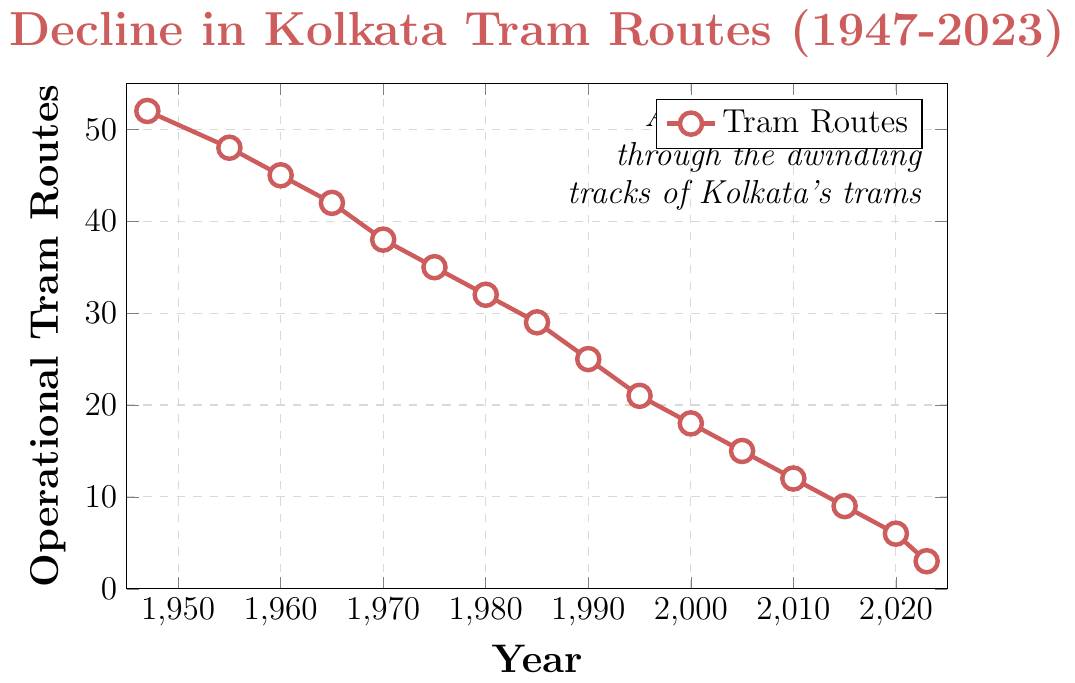What was the number of operational tram routes in 1980? From looking at the figure, the data point for 1980 is at 32.
Answer: 32 How much did the number of tram routes decrease between 1947 and 1965? The number of operational tram routes in 1947 was 52 and in 1965 it was 42. Subtracting 42 from 52 gives the decrease. 52 - 42 = 10
Answer: 10 What is the average number of operational tram routes in the decades 1950, 1960, and 1970? The decades include the years 1950, 1960, and 1970 with values: 48, 45, and 38. Summing them up gives 48 + 45 + 38 = 131, and dividing by 3 gives the average, 131 / 3 ≈ 43.67
Answer: ~43.67 Which year saw the highest number of operational tram routes during the given period? The figure starts from 1947 with the highest number of 52 operational tram routes. This is the maximum data point in the provided data set.
Answer: 1947 By how much did the number of tram routes decrease from 2000 to 2023? The number of tram routes in 2000 was 18 and in 2023 it was 3. Subtracting 3 from 18 gives the decrease. 18 - 3 = 15
Answer: 15 In what year did the number of tram routes first drop below 20? Looking at the drop trends in the data, the first year with tram routes below 20 is 2000, with 18 routes.
Answer: 2000 What is the median number of operational tram routes from 1947 to 2023? To find the median, the numbers need to be ordered: [3, 6, 9, 12, 15, 18, 21, 25, 29, 32, 35, 38, 42, 45, 48, 52]. Since there are 16 data points, the median is the average of the 8th and 9th values. (25 + 21) / 2 = 23
Answer: 23 Which decade saw the largest decrease in operational tram routes, and what was the decrease? Comparing the decade intervals: 
- 1947-1955: 52 - 48 = 4
- 1955-1965: 48 - 42 = 6 
- 1965-1975: 42 - 35 = 7 
- 1975-1985: 35 - 29 = 6 
- 1985-1995: 29 - 21 = 8 
- 1995-2005: 21 - 15 = 6 
- 2005-2015: 15 - 9 = 6 
- 2015-2023: 9 - 3 = 6 
The largest decrease was in the decade 1985-1995 with a reduction of 8.
Answer: 1985-1995, 8 